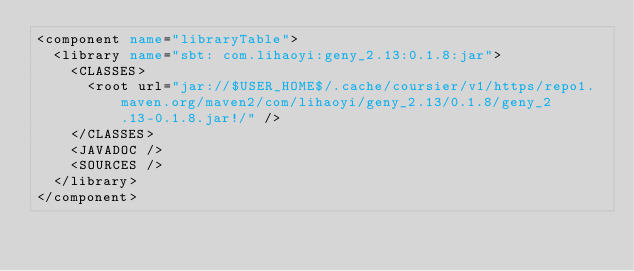<code> <loc_0><loc_0><loc_500><loc_500><_XML_><component name="libraryTable">
  <library name="sbt: com.lihaoyi:geny_2.13:0.1.8:jar">
    <CLASSES>
      <root url="jar://$USER_HOME$/.cache/coursier/v1/https/repo1.maven.org/maven2/com/lihaoyi/geny_2.13/0.1.8/geny_2.13-0.1.8.jar!/" />
    </CLASSES>
    <JAVADOC />
    <SOURCES />
  </library>
</component></code> 